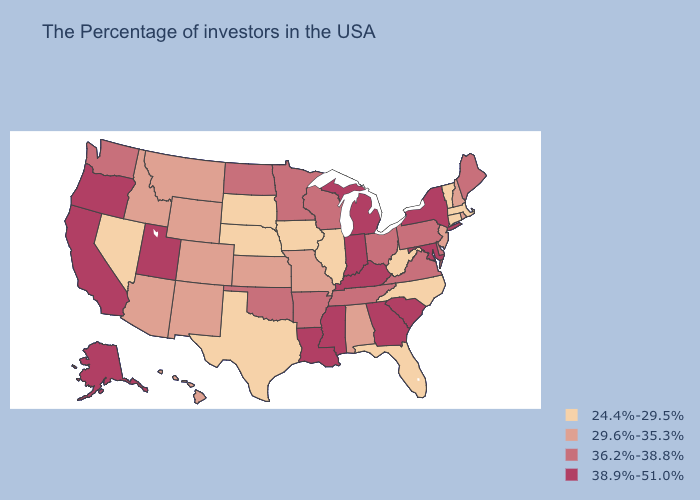What is the value of North Dakota?
Be succinct. 36.2%-38.8%. Does North Dakota have the same value as Vermont?
Keep it brief. No. Does Rhode Island have the highest value in the Northeast?
Give a very brief answer. No. Does Pennsylvania have the same value as Vermont?
Answer briefly. No. Which states have the lowest value in the USA?
Answer briefly. Massachusetts, Vermont, Connecticut, North Carolina, West Virginia, Florida, Illinois, Iowa, Nebraska, Texas, South Dakota, Nevada. What is the value of Montana?
Be succinct. 29.6%-35.3%. Is the legend a continuous bar?
Keep it brief. No. What is the lowest value in the USA?
Answer briefly. 24.4%-29.5%. Does Michigan have a higher value than New Jersey?
Answer briefly. Yes. What is the value of New Jersey?
Write a very short answer. 29.6%-35.3%. Does Missouri have a lower value than Arkansas?
Write a very short answer. Yes. Among the states that border Minnesota , which have the highest value?
Give a very brief answer. Wisconsin, North Dakota. What is the lowest value in the USA?
Keep it brief. 24.4%-29.5%. Does the map have missing data?
Be succinct. No. 